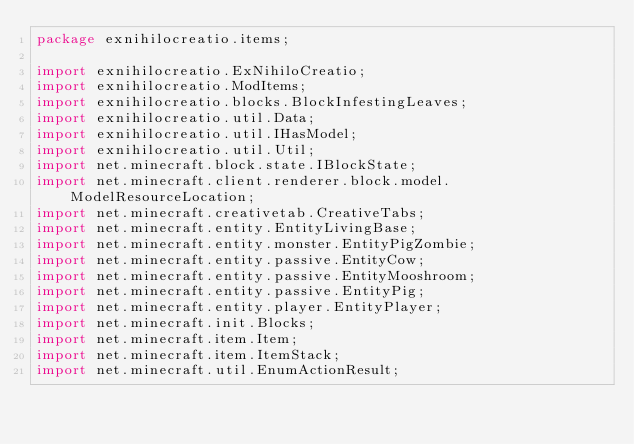<code> <loc_0><loc_0><loc_500><loc_500><_Java_>package exnihilocreatio.items;

import exnihilocreatio.ExNihiloCreatio;
import exnihilocreatio.ModItems;
import exnihilocreatio.blocks.BlockInfestingLeaves;
import exnihilocreatio.util.Data;
import exnihilocreatio.util.IHasModel;
import exnihilocreatio.util.Util;
import net.minecraft.block.state.IBlockState;
import net.minecraft.client.renderer.block.model.ModelResourceLocation;
import net.minecraft.creativetab.CreativeTabs;
import net.minecraft.entity.EntityLivingBase;
import net.minecraft.entity.monster.EntityPigZombie;
import net.minecraft.entity.passive.EntityCow;
import net.minecraft.entity.passive.EntityMooshroom;
import net.minecraft.entity.passive.EntityPig;
import net.minecraft.entity.player.EntityPlayer;
import net.minecraft.init.Blocks;
import net.minecraft.item.Item;
import net.minecraft.item.ItemStack;
import net.minecraft.util.EnumActionResult;</code> 